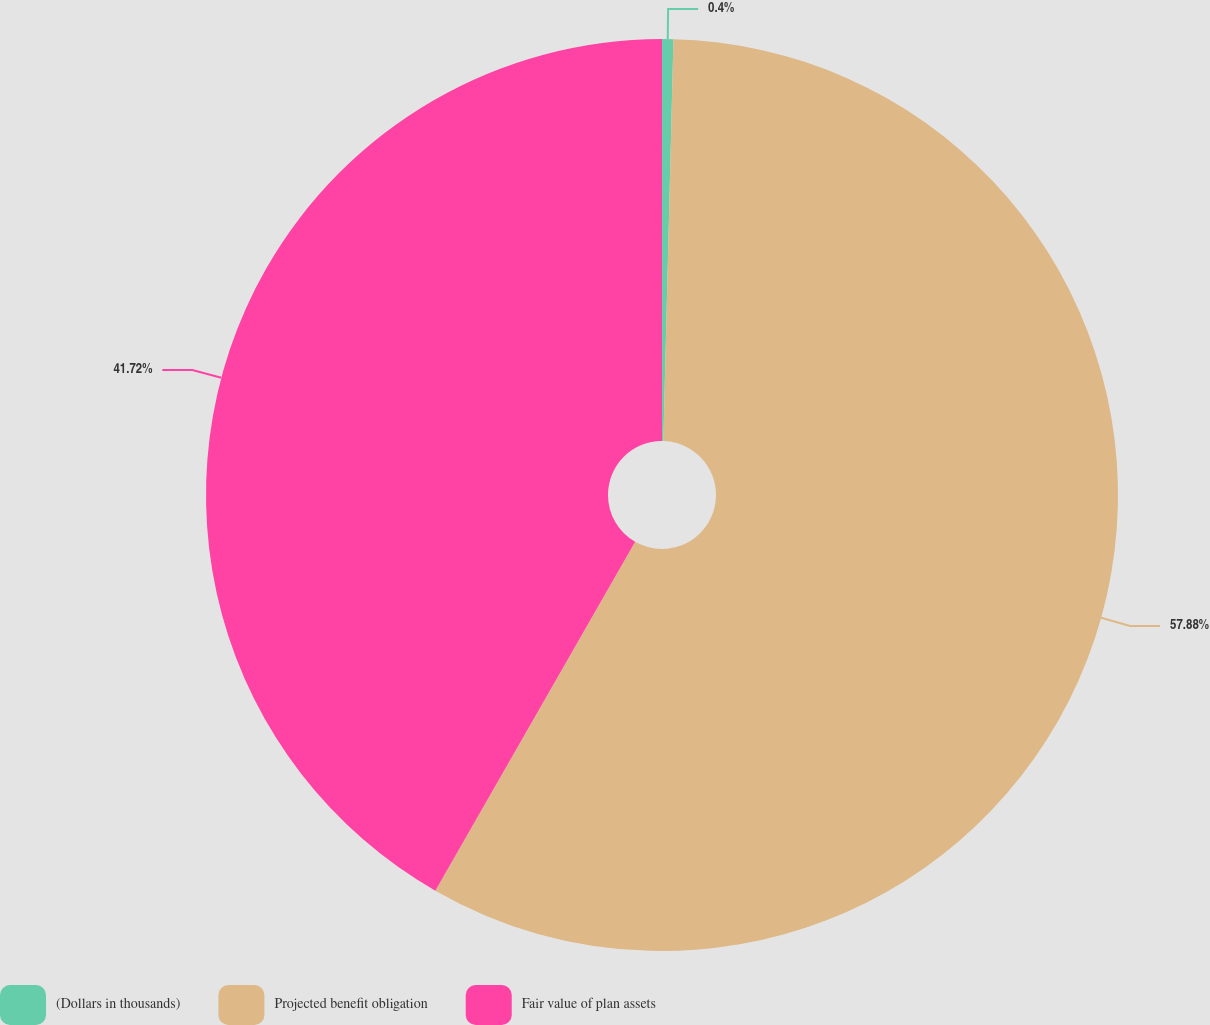Convert chart to OTSL. <chart><loc_0><loc_0><loc_500><loc_500><pie_chart><fcel>(Dollars in thousands)<fcel>Projected benefit obligation<fcel>Fair value of plan assets<nl><fcel>0.4%<fcel>57.88%<fcel>41.72%<nl></chart> 